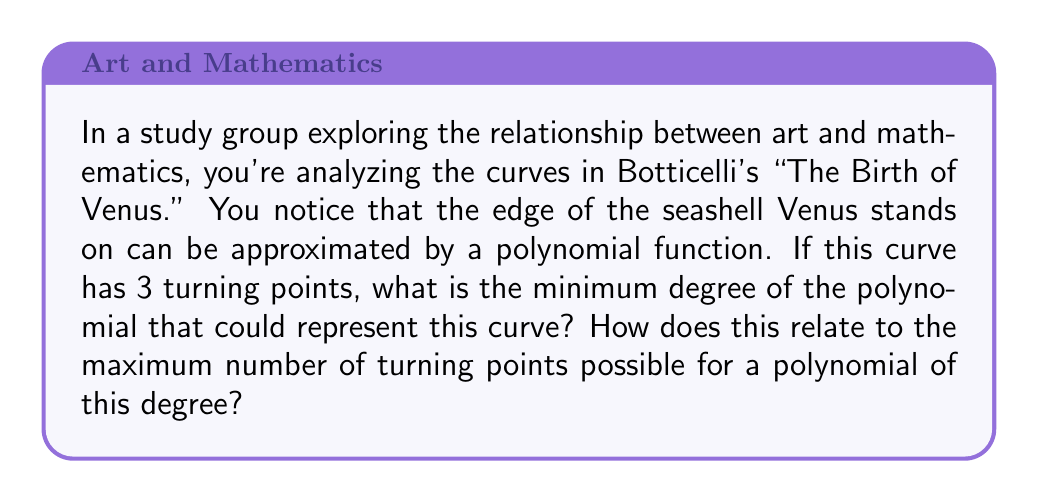Help me with this question. Let's approach this step-by-step:

1) First, recall the relationship between the degree of a polynomial and its maximum number of turning points:
   - For a polynomial of degree $n$, the maximum number of turning points is $n-1$.

2) In this case, we're told the curve has 3 turning points. We need to find the minimum degree that allows for 3 turning points.

3) Let's consider possible degrees:
   - Degree 1: Max turning points = $1-1 = 0$
   - Degree 2: Max turning points = $2-1 = 1$
   - Degree 3: Max turning points = $3-1 = 2$
   - Degree 4: Max turning points = $4-1 = 3$

4) We see that a polynomial of degree 4 is the first to allow for 3 turning points.

5) Therefore, the minimum degree of the polynomial is 4.

6) For a 4th degree polynomial, the maximum number of turning points is indeed $4-1 = 3$.

This means that the curve in Botticelli's painting, if represented by a 4th degree polynomial, is utilizing the maximum number of turning points possible for that degree.
Answer: Minimum degree: 4. Maximum turning points for this degree: 3. 